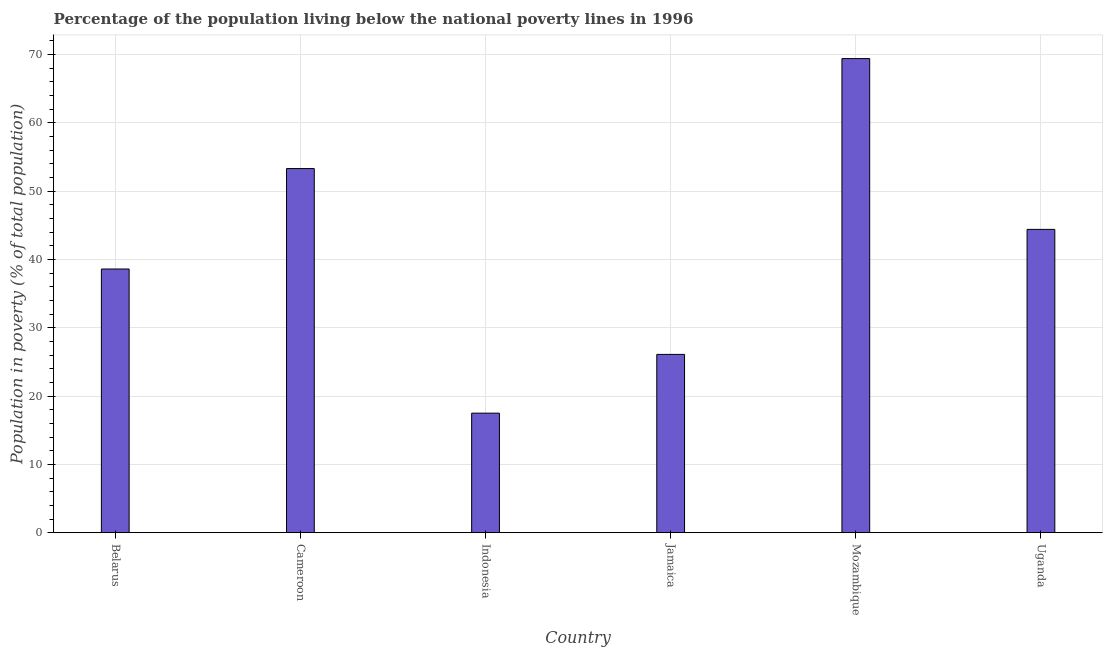Does the graph contain grids?
Offer a very short reply. Yes. What is the title of the graph?
Your answer should be compact. Percentage of the population living below the national poverty lines in 1996. What is the label or title of the X-axis?
Provide a succinct answer. Country. What is the label or title of the Y-axis?
Offer a terse response. Population in poverty (% of total population). What is the percentage of population living below poverty line in Mozambique?
Offer a terse response. 69.4. Across all countries, what is the maximum percentage of population living below poverty line?
Your answer should be compact. 69.4. In which country was the percentage of population living below poverty line maximum?
Give a very brief answer. Mozambique. What is the sum of the percentage of population living below poverty line?
Provide a short and direct response. 249.3. What is the average percentage of population living below poverty line per country?
Provide a succinct answer. 41.55. What is the median percentage of population living below poverty line?
Offer a very short reply. 41.5. What is the ratio of the percentage of population living below poverty line in Mozambique to that in Uganda?
Keep it short and to the point. 1.56. Is the difference between the percentage of population living below poverty line in Belarus and Indonesia greater than the difference between any two countries?
Your response must be concise. No. What is the difference between the highest and the lowest percentage of population living below poverty line?
Your answer should be very brief. 51.9. In how many countries, is the percentage of population living below poverty line greater than the average percentage of population living below poverty line taken over all countries?
Offer a terse response. 3. Are all the bars in the graph horizontal?
Provide a short and direct response. No. Are the values on the major ticks of Y-axis written in scientific E-notation?
Give a very brief answer. No. What is the Population in poverty (% of total population) of Belarus?
Offer a terse response. 38.6. What is the Population in poverty (% of total population) in Cameroon?
Your answer should be compact. 53.3. What is the Population in poverty (% of total population) in Jamaica?
Provide a succinct answer. 26.1. What is the Population in poverty (% of total population) of Mozambique?
Provide a short and direct response. 69.4. What is the Population in poverty (% of total population) in Uganda?
Make the answer very short. 44.4. What is the difference between the Population in poverty (% of total population) in Belarus and Cameroon?
Your answer should be very brief. -14.7. What is the difference between the Population in poverty (% of total population) in Belarus and Indonesia?
Provide a short and direct response. 21.1. What is the difference between the Population in poverty (% of total population) in Belarus and Jamaica?
Make the answer very short. 12.5. What is the difference between the Population in poverty (% of total population) in Belarus and Mozambique?
Your answer should be very brief. -30.8. What is the difference between the Population in poverty (% of total population) in Belarus and Uganda?
Your answer should be compact. -5.8. What is the difference between the Population in poverty (% of total population) in Cameroon and Indonesia?
Your answer should be very brief. 35.8. What is the difference between the Population in poverty (% of total population) in Cameroon and Jamaica?
Ensure brevity in your answer.  27.2. What is the difference between the Population in poverty (% of total population) in Cameroon and Mozambique?
Provide a short and direct response. -16.1. What is the difference between the Population in poverty (% of total population) in Indonesia and Jamaica?
Provide a succinct answer. -8.6. What is the difference between the Population in poverty (% of total population) in Indonesia and Mozambique?
Provide a short and direct response. -51.9. What is the difference between the Population in poverty (% of total population) in Indonesia and Uganda?
Your response must be concise. -26.9. What is the difference between the Population in poverty (% of total population) in Jamaica and Mozambique?
Make the answer very short. -43.3. What is the difference between the Population in poverty (% of total population) in Jamaica and Uganda?
Provide a short and direct response. -18.3. What is the ratio of the Population in poverty (% of total population) in Belarus to that in Cameroon?
Keep it short and to the point. 0.72. What is the ratio of the Population in poverty (% of total population) in Belarus to that in Indonesia?
Keep it short and to the point. 2.21. What is the ratio of the Population in poverty (% of total population) in Belarus to that in Jamaica?
Give a very brief answer. 1.48. What is the ratio of the Population in poverty (% of total population) in Belarus to that in Mozambique?
Your response must be concise. 0.56. What is the ratio of the Population in poverty (% of total population) in Belarus to that in Uganda?
Provide a short and direct response. 0.87. What is the ratio of the Population in poverty (% of total population) in Cameroon to that in Indonesia?
Offer a terse response. 3.05. What is the ratio of the Population in poverty (% of total population) in Cameroon to that in Jamaica?
Provide a short and direct response. 2.04. What is the ratio of the Population in poverty (% of total population) in Cameroon to that in Mozambique?
Ensure brevity in your answer.  0.77. What is the ratio of the Population in poverty (% of total population) in Cameroon to that in Uganda?
Ensure brevity in your answer.  1.2. What is the ratio of the Population in poverty (% of total population) in Indonesia to that in Jamaica?
Provide a succinct answer. 0.67. What is the ratio of the Population in poverty (% of total population) in Indonesia to that in Mozambique?
Offer a terse response. 0.25. What is the ratio of the Population in poverty (% of total population) in Indonesia to that in Uganda?
Your answer should be very brief. 0.39. What is the ratio of the Population in poverty (% of total population) in Jamaica to that in Mozambique?
Your answer should be very brief. 0.38. What is the ratio of the Population in poverty (% of total population) in Jamaica to that in Uganda?
Give a very brief answer. 0.59. What is the ratio of the Population in poverty (% of total population) in Mozambique to that in Uganda?
Provide a succinct answer. 1.56. 